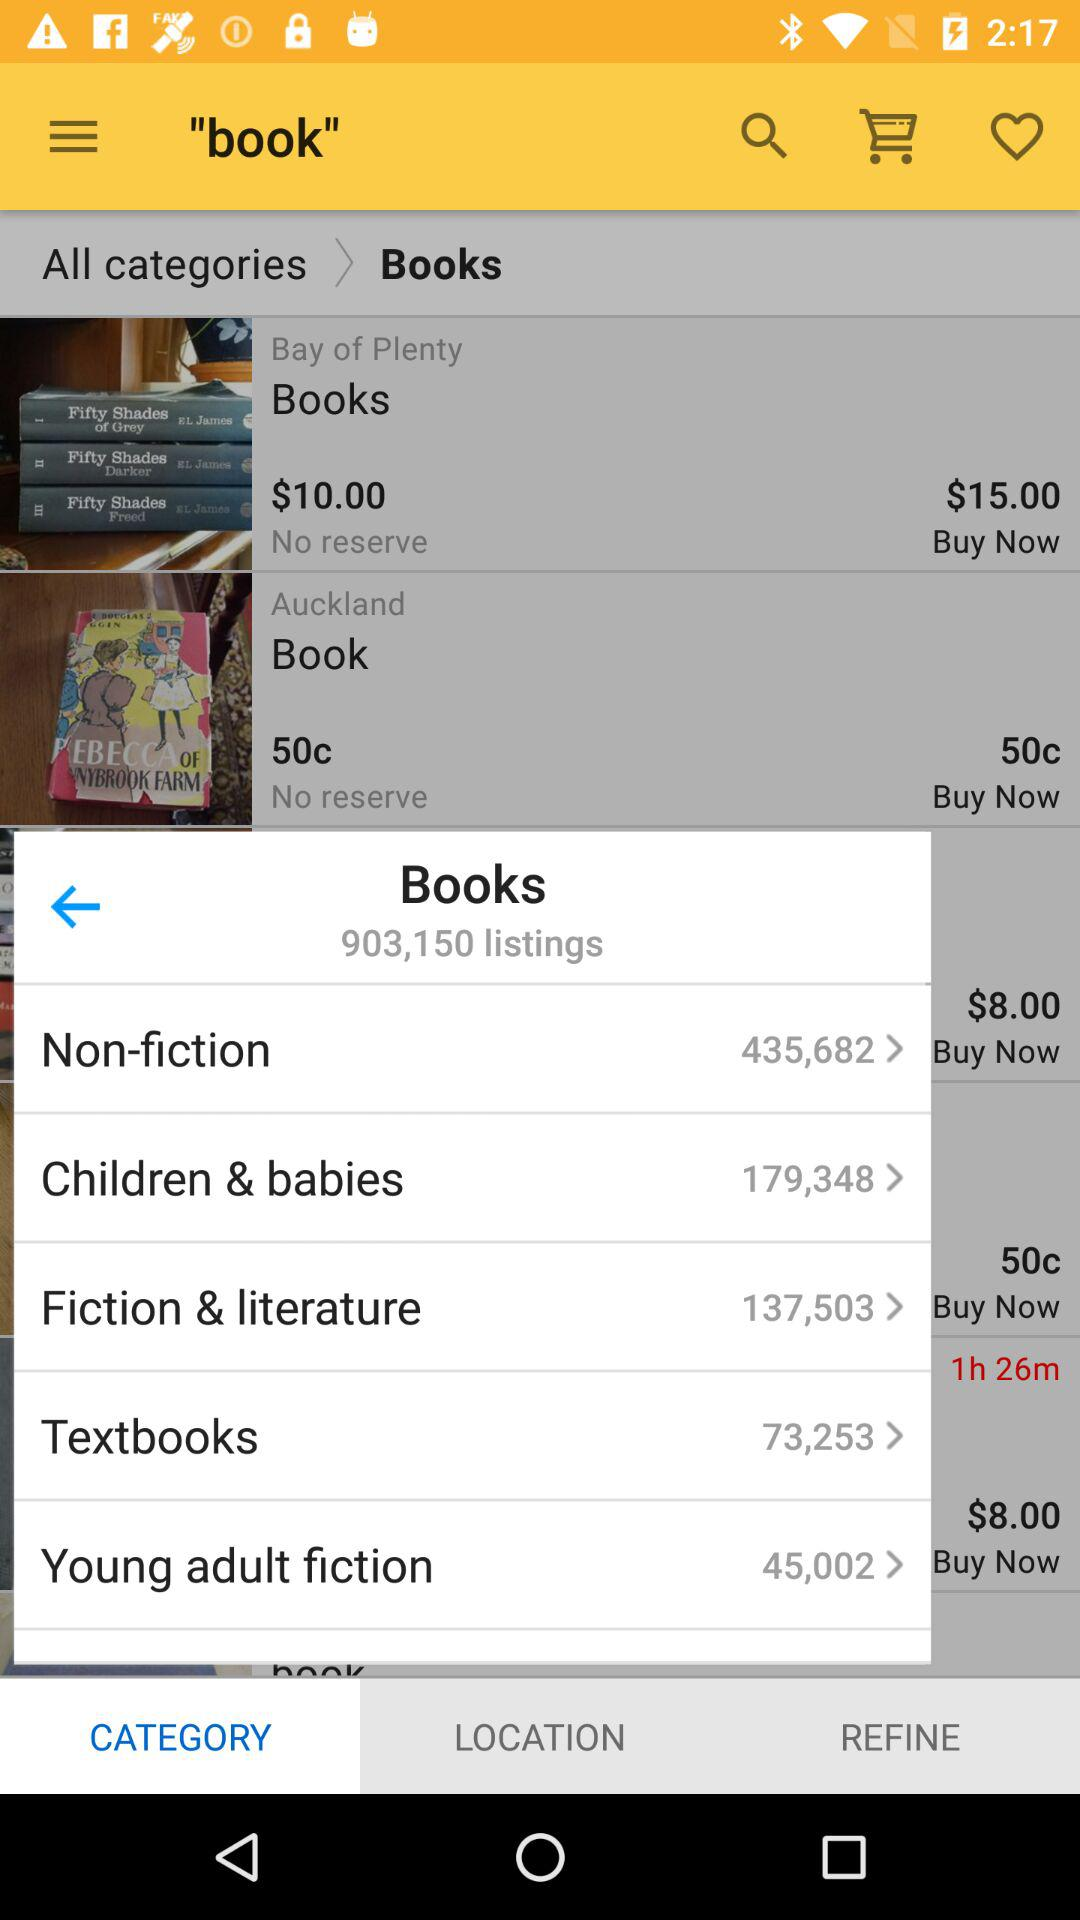What are the different categories of available books? The different categories are "Non-fiction", "Children & babies", "Fiction & literature", "Textbooks" and "Young adult fiction". 